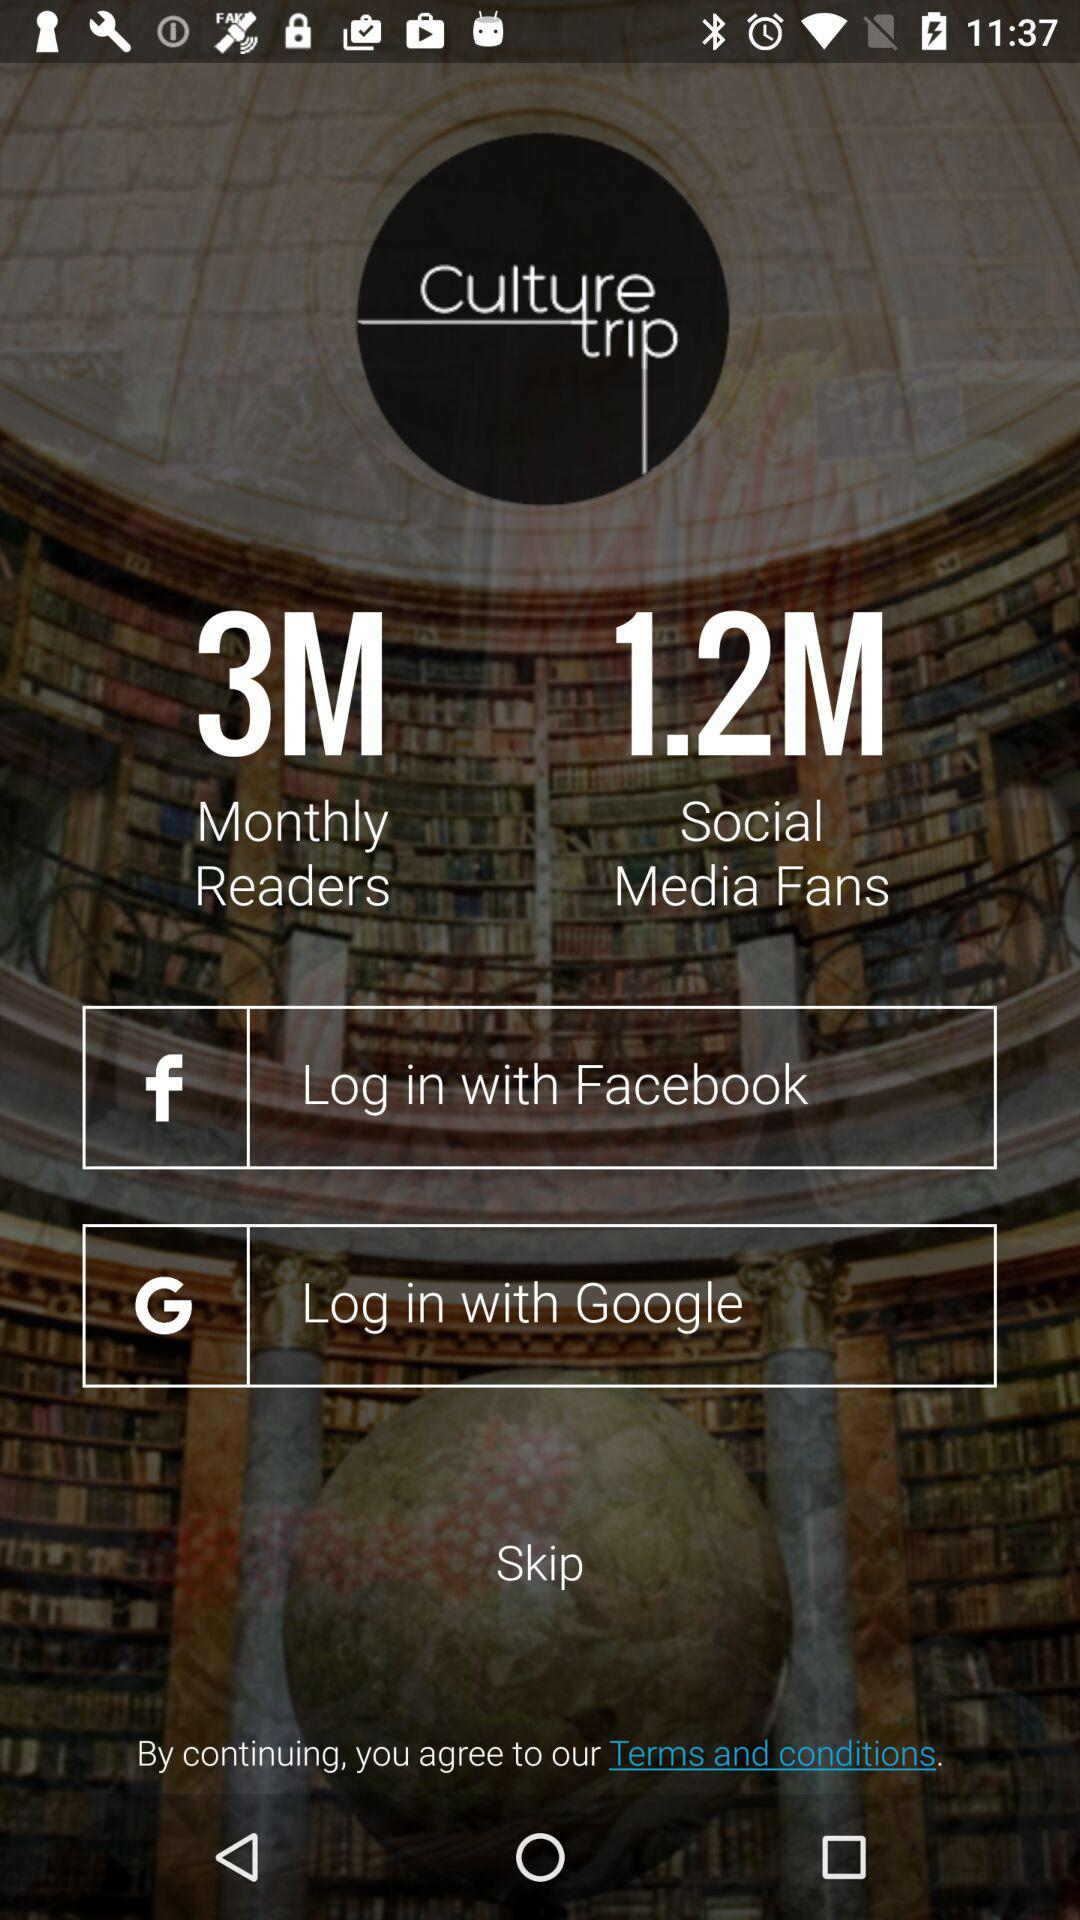What information will "Culture Trip" receive? "Culture Trip" will receive your public profile, friend list and email address. 